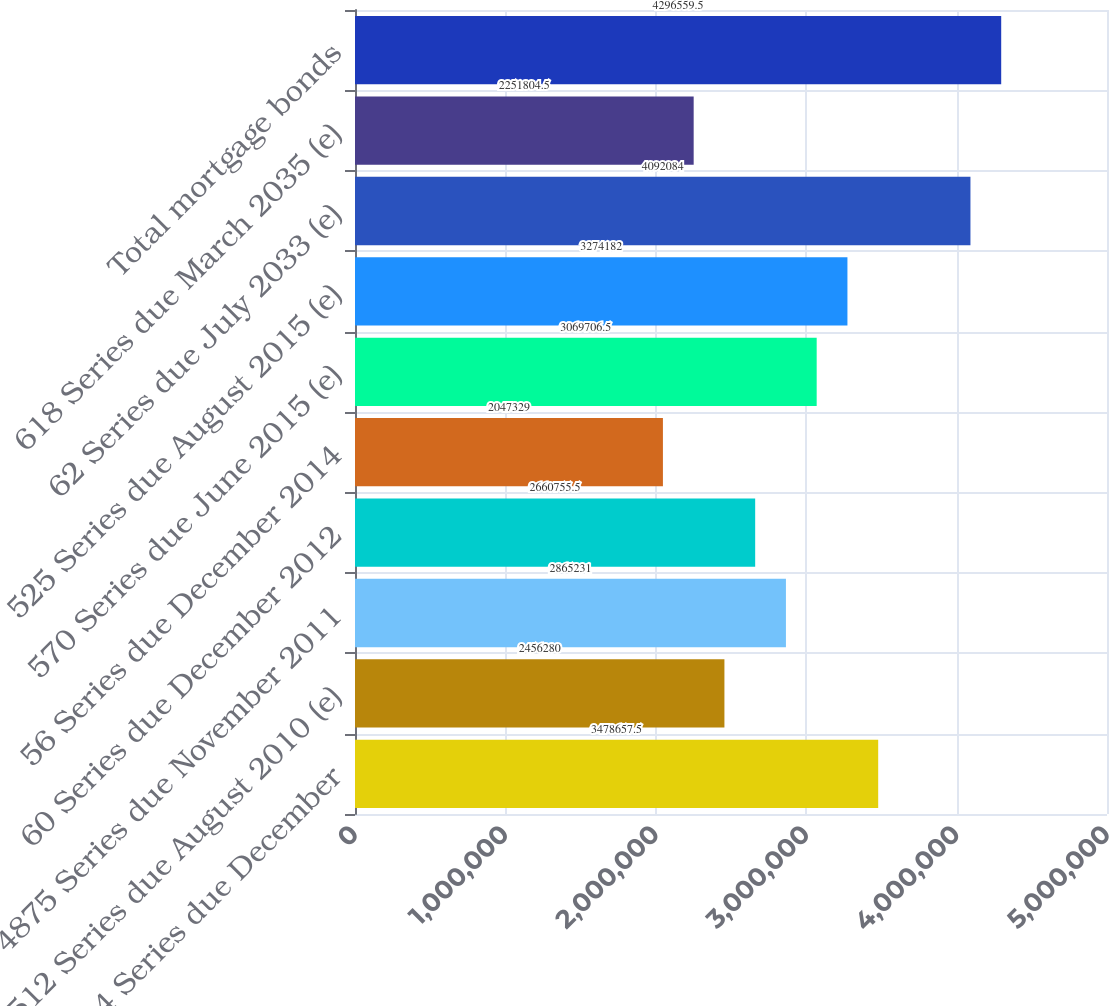Convert chart to OTSL. <chart><loc_0><loc_0><loc_500><loc_500><bar_chart><fcel>Libor + 04 Series due December<fcel>512 Series due August 2010 (e)<fcel>4875 Series due November 2011<fcel>60 Series due December 2012<fcel>56 Series due December 2014<fcel>570 Series due June 2015 (e)<fcel>525 Series due August 2015 (e)<fcel>62 Series due July 2033 (e)<fcel>618 Series due March 2035 (e)<fcel>Total mortgage bonds<nl><fcel>3.47866e+06<fcel>2.45628e+06<fcel>2.86523e+06<fcel>2.66076e+06<fcel>2.04733e+06<fcel>3.06971e+06<fcel>3.27418e+06<fcel>4.09208e+06<fcel>2.2518e+06<fcel>4.29656e+06<nl></chart> 